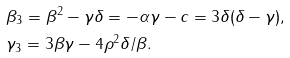Convert formula to latex. <formula><loc_0><loc_0><loc_500><loc_500>& \beta _ { 3 } = \beta ^ { 2 } - \gamma \delta = - \alpha \gamma - c = 3 \delta ( \delta - \gamma ) , \\ & \gamma _ { 3 } = 3 \beta \gamma - 4 \rho ^ { 2 } \delta / \beta .</formula> 